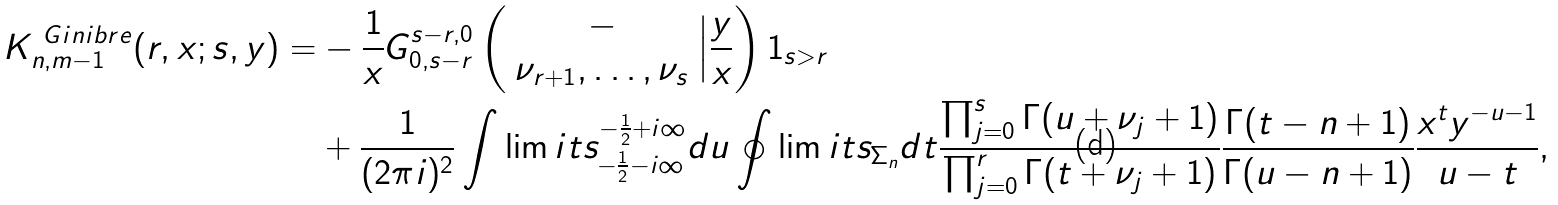<formula> <loc_0><loc_0><loc_500><loc_500>K _ { n , m - 1 } ^ { \ G i n i b r e } ( r , x ; s , y ) = & - \frac { 1 } { x } G ^ { s - r , 0 } _ { 0 , s - r } \left ( \begin{array} { c c c } - \\ \nu _ { r + 1 } , \dots , \nu _ { s } \end{array} \Big | \frac { y } { x } \right ) 1 _ { s > r } \\ & + \frac { 1 } { ( 2 \pi i ) ^ { 2 } } \int \lim i t s _ { - \frac { 1 } { 2 } - i \infty } ^ { - \frac { 1 } { 2 } + i \infty } d u \oint \lim i t s _ { \Sigma _ { n } } d t \frac { \prod _ { j = 0 } ^ { s } \Gamma ( u + \nu _ { j } + 1 ) } { \prod _ { j = 0 } ^ { r } \Gamma ( t + \nu _ { j } + 1 ) } \frac { \Gamma ( t - n + 1 ) } { \Gamma ( u - n + 1 ) } \frac { x ^ { t } y ^ { - u - 1 } } { u - t } ,</formula> 